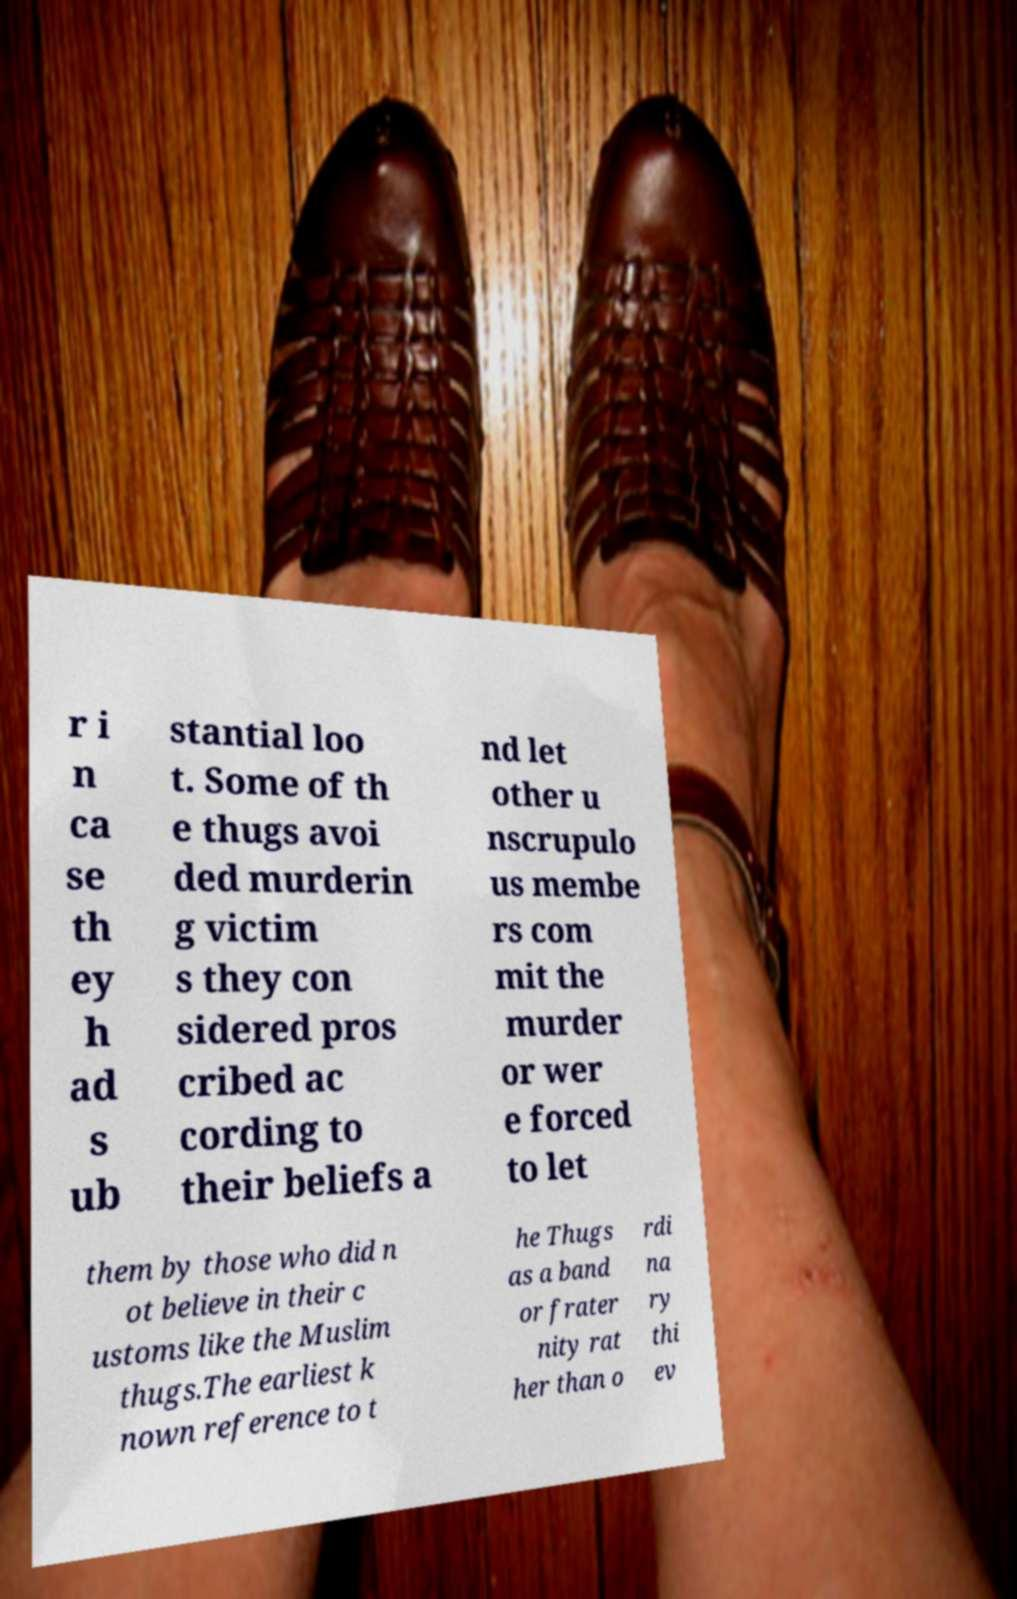I need the written content from this picture converted into text. Can you do that? r i n ca se th ey h ad s ub stantial loo t. Some of th e thugs avoi ded murderin g victim s they con sidered pros cribed ac cording to their beliefs a nd let other u nscrupulo us membe rs com mit the murder or wer e forced to let them by those who did n ot believe in their c ustoms like the Muslim thugs.The earliest k nown reference to t he Thugs as a band or frater nity rat her than o rdi na ry thi ev 